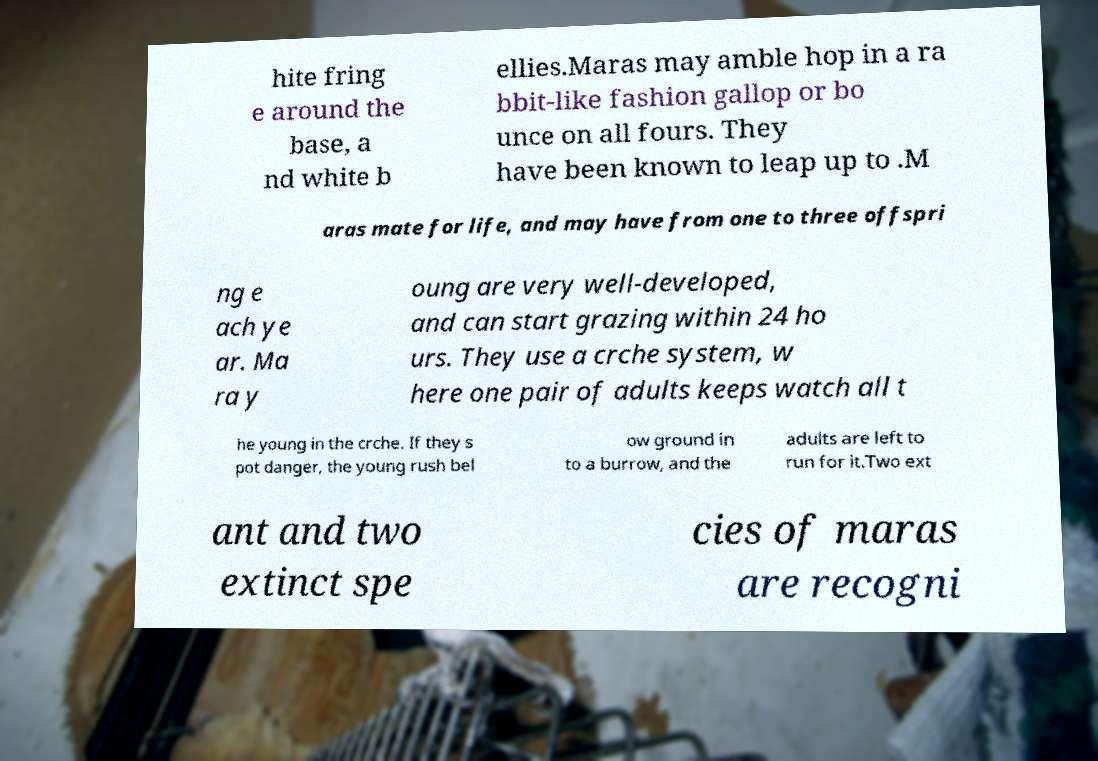Please read and relay the text visible in this image. What does it say? hite fring e around the base, a nd white b ellies.Maras may amble hop in a ra bbit-like fashion gallop or bo unce on all fours. They have been known to leap up to .M aras mate for life, and may have from one to three offspri ng e ach ye ar. Ma ra y oung are very well-developed, and can start grazing within 24 ho urs. They use a crche system, w here one pair of adults keeps watch all t he young in the crche. If they s pot danger, the young rush bel ow ground in to a burrow, and the adults are left to run for it.Two ext ant and two extinct spe cies of maras are recogni 